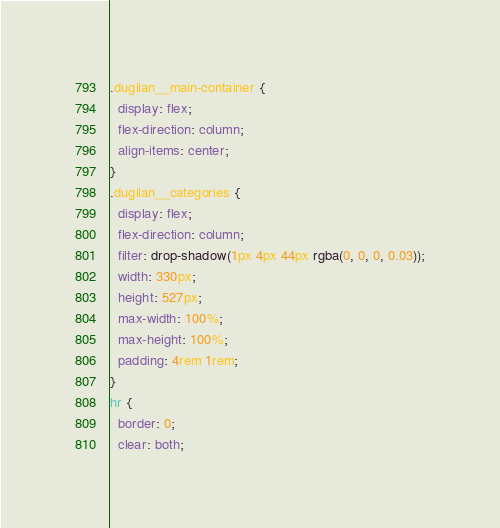Convert code to text. <code><loc_0><loc_0><loc_500><loc_500><_CSS_>.dugilan__main-container {
  display: flex;
  flex-direction: column;
  align-items: center;
}
.dugilan__categories {
  display: flex;
  flex-direction: column;
  filter: drop-shadow(1px 4px 44px rgba(0, 0, 0, 0.03));
  width: 330px;
  height: 527px;
  max-width: 100%;
  max-height: 100%;
  padding: 4rem 1rem;
}
hr {
  border: 0;
  clear: both;</code> 